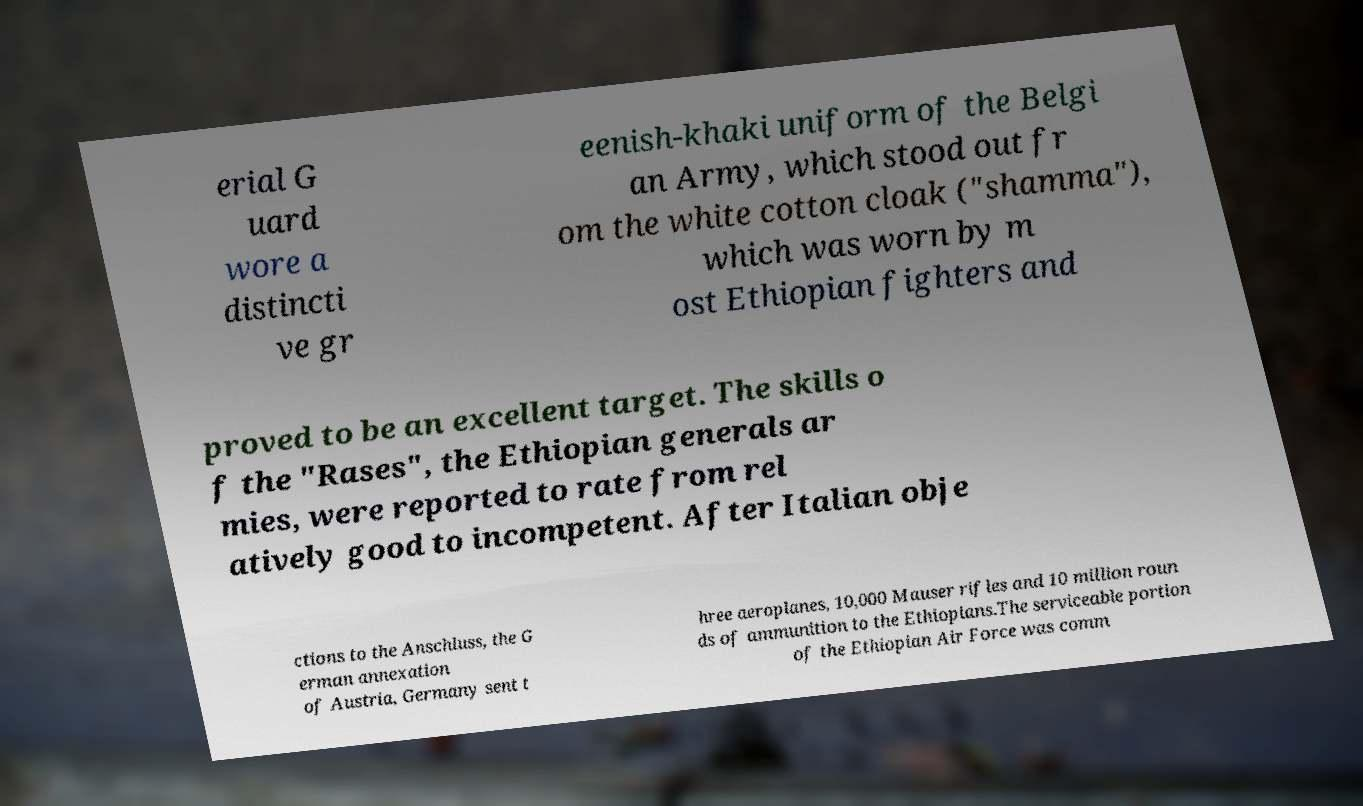Please identify and transcribe the text found in this image. erial G uard wore a distincti ve gr eenish-khaki uniform of the Belgi an Army, which stood out fr om the white cotton cloak ("shamma"), which was worn by m ost Ethiopian fighters and proved to be an excellent target. The skills o f the "Rases", the Ethiopian generals ar mies, were reported to rate from rel atively good to incompetent. After Italian obje ctions to the Anschluss, the G erman annexation of Austria, Germany sent t hree aeroplanes, 10,000 Mauser rifles and 10 million roun ds of ammunition to the Ethiopians.The serviceable portion of the Ethiopian Air Force was comm 